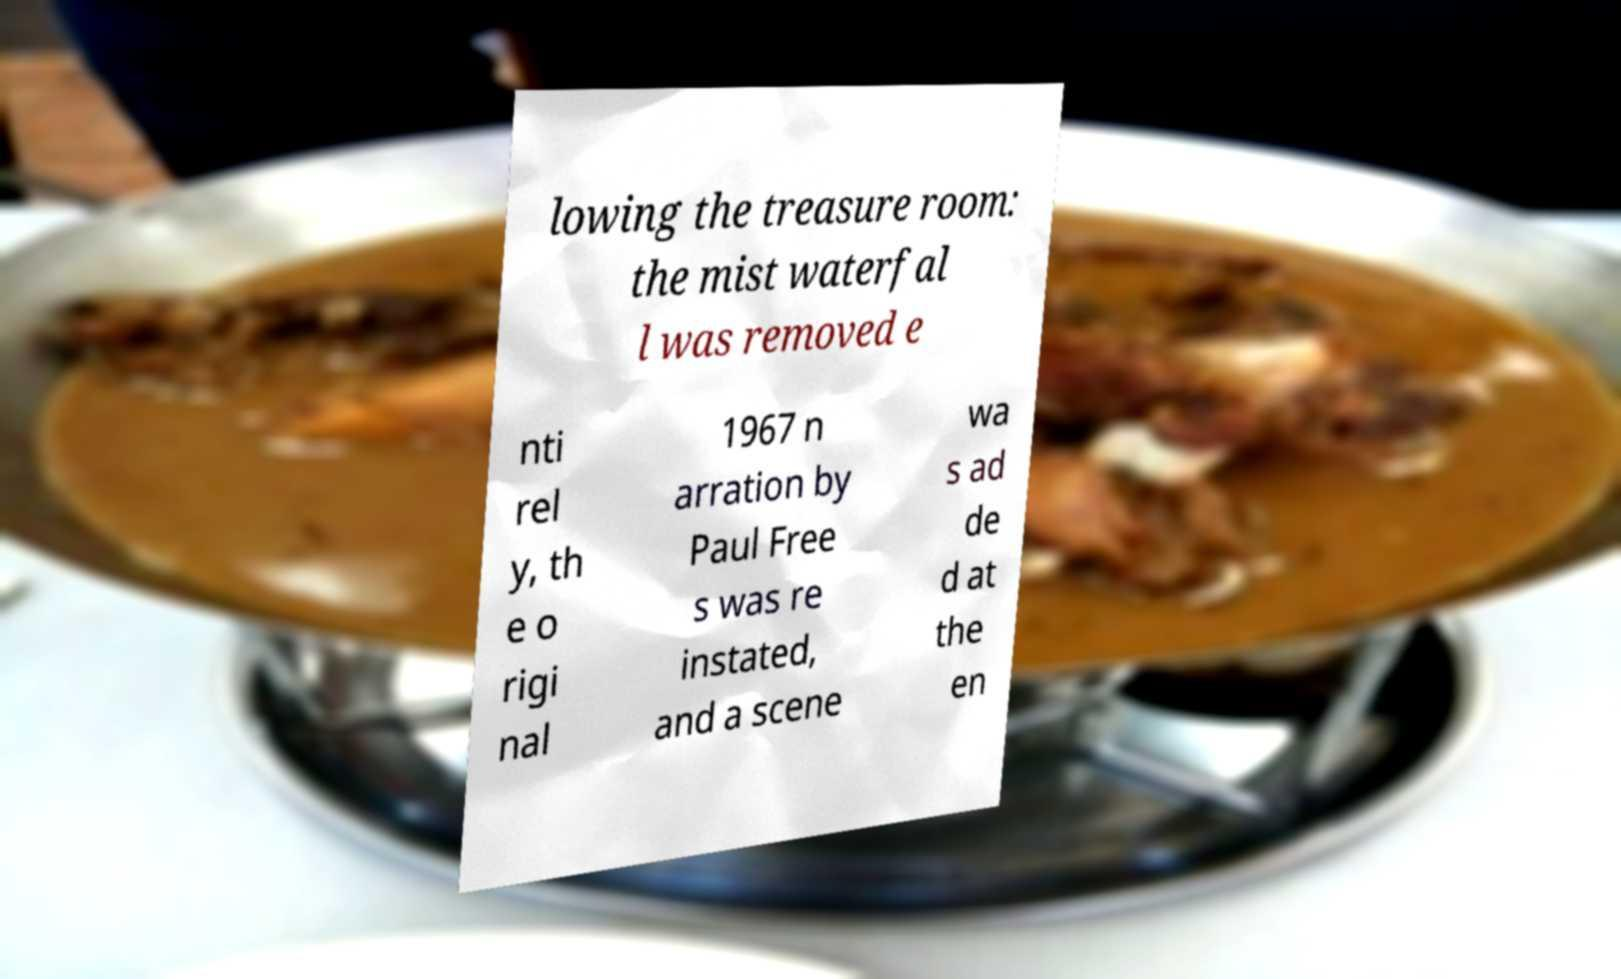Please read and relay the text visible in this image. What does it say? lowing the treasure room: the mist waterfal l was removed e nti rel y, th e o rigi nal 1967 n arration by Paul Free s was re instated, and a scene wa s ad de d at the en 